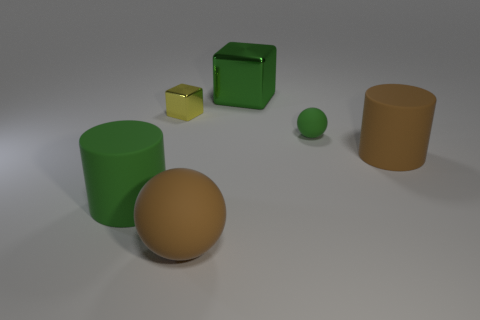Subtract all green spheres. How many spheres are left? 1 Subtract 1 spheres. How many spheres are left? 1 Add 3 large cyan cylinders. How many objects exist? 9 Subtract all blocks. How many objects are left? 4 Add 6 big balls. How many big balls are left? 7 Add 1 large green rubber objects. How many large green rubber objects exist? 2 Subtract 1 yellow blocks. How many objects are left? 5 Subtract all purple blocks. Subtract all red spheres. How many blocks are left? 2 Subtract all red balls. How many green blocks are left? 1 Subtract all big cyan rubber balls. Subtract all green balls. How many objects are left? 5 